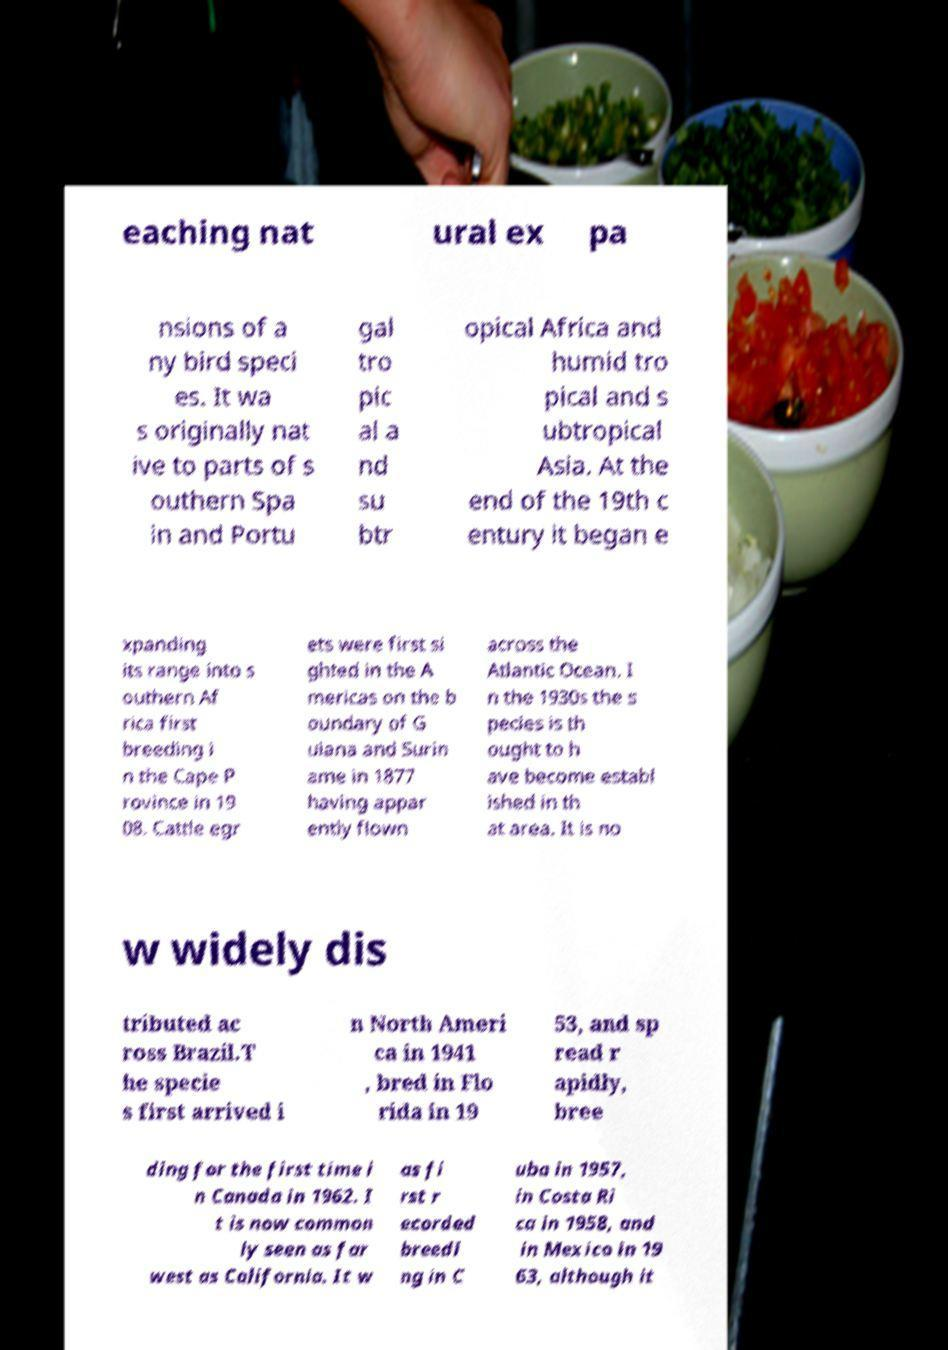Please read and relay the text visible in this image. What does it say? eaching nat ural ex pa nsions of a ny bird speci es. It wa s originally nat ive to parts of s outhern Spa in and Portu gal tro pic al a nd su btr opical Africa and humid tro pical and s ubtropical Asia. At the end of the 19th c entury it began e xpanding its range into s outhern Af rica first breeding i n the Cape P rovince in 19 08. Cattle egr ets were first si ghted in the A mericas on the b oundary of G uiana and Surin ame in 1877 having appar ently flown across the Atlantic Ocean. I n the 1930s the s pecies is th ought to h ave become establ ished in th at area. It is no w widely dis tributed ac ross Brazil.T he specie s first arrived i n North Ameri ca in 1941 , bred in Flo rida in 19 53, and sp read r apidly, bree ding for the first time i n Canada in 1962. I t is now common ly seen as far west as California. It w as fi rst r ecorded breedi ng in C uba in 1957, in Costa Ri ca in 1958, and in Mexico in 19 63, although it 